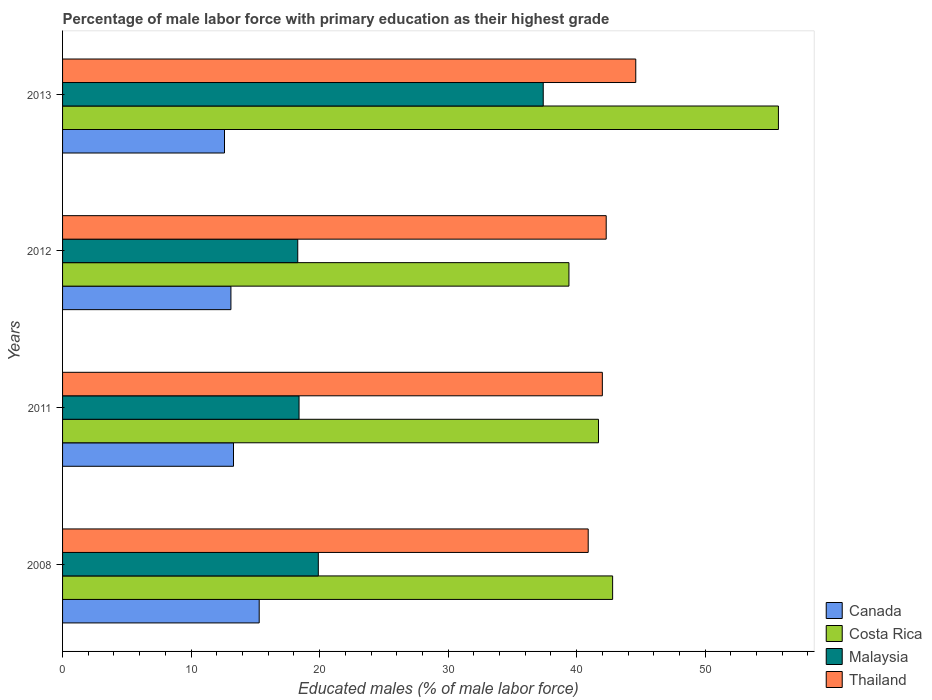How many bars are there on the 4th tick from the bottom?
Your response must be concise. 4. What is the label of the 3rd group of bars from the top?
Give a very brief answer. 2011. What is the percentage of male labor force with primary education in Malaysia in 2008?
Make the answer very short. 19.9. Across all years, what is the maximum percentage of male labor force with primary education in Malaysia?
Provide a succinct answer. 37.4. Across all years, what is the minimum percentage of male labor force with primary education in Thailand?
Offer a terse response. 40.9. In which year was the percentage of male labor force with primary education in Costa Rica maximum?
Provide a short and direct response. 2013. What is the total percentage of male labor force with primary education in Thailand in the graph?
Provide a succinct answer. 169.8. What is the difference between the percentage of male labor force with primary education in Malaysia in 2008 and that in 2012?
Your answer should be very brief. 1.6. What is the difference between the percentage of male labor force with primary education in Malaysia in 2011 and the percentage of male labor force with primary education in Thailand in 2008?
Keep it short and to the point. -22.5. What is the average percentage of male labor force with primary education in Canada per year?
Offer a very short reply. 13.58. In the year 2011, what is the difference between the percentage of male labor force with primary education in Costa Rica and percentage of male labor force with primary education in Malaysia?
Provide a succinct answer. 23.3. What is the ratio of the percentage of male labor force with primary education in Costa Rica in 2008 to that in 2013?
Ensure brevity in your answer.  0.77. What is the difference between the highest and the second highest percentage of male labor force with primary education in Malaysia?
Make the answer very short. 17.5. What is the difference between the highest and the lowest percentage of male labor force with primary education in Thailand?
Your answer should be compact. 3.7. In how many years, is the percentage of male labor force with primary education in Malaysia greater than the average percentage of male labor force with primary education in Malaysia taken over all years?
Offer a very short reply. 1. Is it the case that in every year, the sum of the percentage of male labor force with primary education in Canada and percentage of male labor force with primary education in Malaysia is greater than the sum of percentage of male labor force with primary education in Thailand and percentage of male labor force with primary education in Costa Rica?
Keep it short and to the point. No. What does the 4th bar from the top in 2012 represents?
Provide a succinct answer. Canada. What does the 3rd bar from the bottom in 2011 represents?
Make the answer very short. Malaysia. How many bars are there?
Offer a very short reply. 16. Are all the bars in the graph horizontal?
Provide a short and direct response. Yes. Where does the legend appear in the graph?
Offer a terse response. Bottom right. How many legend labels are there?
Your answer should be compact. 4. How are the legend labels stacked?
Give a very brief answer. Vertical. What is the title of the graph?
Offer a very short reply. Percentage of male labor force with primary education as their highest grade. What is the label or title of the X-axis?
Provide a short and direct response. Educated males (% of male labor force). What is the Educated males (% of male labor force) in Canada in 2008?
Offer a very short reply. 15.3. What is the Educated males (% of male labor force) of Costa Rica in 2008?
Offer a very short reply. 42.8. What is the Educated males (% of male labor force) in Malaysia in 2008?
Provide a short and direct response. 19.9. What is the Educated males (% of male labor force) of Thailand in 2008?
Keep it short and to the point. 40.9. What is the Educated males (% of male labor force) in Canada in 2011?
Offer a very short reply. 13.3. What is the Educated males (% of male labor force) of Costa Rica in 2011?
Offer a terse response. 41.7. What is the Educated males (% of male labor force) of Malaysia in 2011?
Your answer should be compact. 18.4. What is the Educated males (% of male labor force) in Thailand in 2011?
Give a very brief answer. 42. What is the Educated males (% of male labor force) in Canada in 2012?
Your answer should be compact. 13.1. What is the Educated males (% of male labor force) in Costa Rica in 2012?
Your answer should be very brief. 39.4. What is the Educated males (% of male labor force) in Malaysia in 2012?
Your answer should be compact. 18.3. What is the Educated males (% of male labor force) of Thailand in 2012?
Provide a short and direct response. 42.3. What is the Educated males (% of male labor force) of Canada in 2013?
Provide a succinct answer. 12.6. What is the Educated males (% of male labor force) in Costa Rica in 2013?
Offer a terse response. 55.7. What is the Educated males (% of male labor force) of Malaysia in 2013?
Your answer should be compact. 37.4. What is the Educated males (% of male labor force) in Thailand in 2013?
Offer a terse response. 44.6. Across all years, what is the maximum Educated males (% of male labor force) in Canada?
Offer a terse response. 15.3. Across all years, what is the maximum Educated males (% of male labor force) of Costa Rica?
Give a very brief answer. 55.7. Across all years, what is the maximum Educated males (% of male labor force) in Malaysia?
Your answer should be very brief. 37.4. Across all years, what is the maximum Educated males (% of male labor force) of Thailand?
Ensure brevity in your answer.  44.6. Across all years, what is the minimum Educated males (% of male labor force) of Canada?
Make the answer very short. 12.6. Across all years, what is the minimum Educated males (% of male labor force) in Costa Rica?
Your response must be concise. 39.4. Across all years, what is the minimum Educated males (% of male labor force) of Malaysia?
Your response must be concise. 18.3. Across all years, what is the minimum Educated males (% of male labor force) of Thailand?
Make the answer very short. 40.9. What is the total Educated males (% of male labor force) of Canada in the graph?
Offer a very short reply. 54.3. What is the total Educated males (% of male labor force) of Costa Rica in the graph?
Make the answer very short. 179.6. What is the total Educated males (% of male labor force) of Malaysia in the graph?
Offer a very short reply. 94. What is the total Educated males (% of male labor force) in Thailand in the graph?
Ensure brevity in your answer.  169.8. What is the difference between the Educated males (% of male labor force) of Costa Rica in 2008 and that in 2011?
Your answer should be very brief. 1.1. What is the difference between the Educated males (% of male labor force) in Malaysia in 2008 and that in 2011?
Offer a terse response. 1.5. What is the difference between the Educated males (% of male labor force) of Malaysia in 2008 and that in 2012?
Provide a short and direct response. 1.6. What is the difference between the Educated males (% of male labor force) in Canada in 2008 and that in 2013?
Your answer should be compact. 2.7. What is the difference between the Educated males (% of male labor force) of Malaysia in 2008 and that in 2013?
Offer a very short reply. -17.5. What is the difference between the Educated males (% of male labor force) of Thailand in 2008 and that in 2013?
Offer a terse response. -3.7. What is the difference between the Educated males (% of male labor force) in Canada in 2011 and that in 2012?
Keep it short and to the point. 0.2. What is the difference between the Educated males (% of male labor force) in Costa Rica in 2011 and that in 2012?
Ensure brevity in your answer.  2.3. What is the difference between the Educated males (% of male labor force) in Costa Rica in 2011 and that in 2013?
Keep it short and to the point. -14. What is the difference between the Educated males (% of male labor force) in Malaysia in 2011 and that in 2013?
Offer a very short reply. -19. What is the difference between the Educated males (% of male labor force) of Costa Rica in 2012 and that in 2013?
Ensure brevity in your answer.  -16.3. What is the difference between the Educated males (% of male labor force) of Malaysia in 2012 and that in 2013?
Provide a succinct answer. -19.1. What is the difference between the Educated males (% of male labor force) of Thailand in 2012 and that in 2013?
Provide a short and direct response. -2.3. What is the difference between the Educated males (% of male labor force) in Canada in 2008 and the Educated males (% of male labor force) in Costa Rica in 2011?
Keep it short and to the point. -26.4. What is the difference between the Educated males (% of male labor force) in Canada in 2008 and the Educated males (% of male labor force) in Thailand in 2011?
Your answer should be very brief. -26.7. What is the difference between the Educated males (% of male labor force) in Costa Rica in 2008 and the Educated males (% of male labor force) in Malaysia in 2011?
Offer a very short reply. 24.4. What is the difference between the Educated males (% of male labor force) of Malaysia in 2008 and the Educated males (% of male labor force) of Thailand in 2011?
Provide a succinct answer. -22.1. What is the difference between the Educated males (% of male labor force) in Canada in 2008 and the Educated males (% of male labor force) in Costa Rica in 2012?
Keep it short and to the point. -24.1. What is the difference between the Educated males (% of male labor force) of Canada in 2008 and the Educated males (% of male labor force) of Malaysia in 2012?
Your answer should be compact. -3. What is the difference between the Educated males (% of male labor force) of Canada in 2008 and the Educated males (% of male labor force) of Thailand in 2012?
Your answer should be compact. -27. What is the difference between the Educated males (% of male labor force) of Costa Rica in 2008 and the Educated males (% of male labor force) of Malaysia in 2012?
Offer a very short reply. 24.5. What is the difference between the Educated males (% of male labor force) in Malaysia in 2008 and the Educated males (% of male labor force) in Thailand in 2012?
Keep it short and to the point. -22.4. What is the difference between the Educated males (% of male labor force) of Canada in 2008 and the Educated males (% of male labor force) of Costa Rica in 2013?
Your answer should be compact. -40.4. What is the difference between the Educated males (% of male labor force) in Canada in 2008 and the Educated males (% of male labor force) in Malaysia in 2013?
Make the answer very short. -22.1. What is the difference between the Educated males (% of male labor force) of Canada in 2008 and the Educated males (% of male labor force) of Thailand in 2013?
Make the answer very short. -29.3. What is the difference between the Educated males (% of male labor force) of Costa Rica in 2008 and the Educated males (% of male labor force) of Malaysia in 2013?
Offer a very short reply. 5.4. What is the difference between the Educated males (% of male labor force) in Malaysia in 2008 and the Educated males (% of male labor force) in Thailand in 2013?
Provide a short and direct response. -24.7. What is the difference between the Educated males (% of male labor force) of Canada in 2011 and the Educated males (% of male labor force) of Costa Rica in 2012?
Offer a terse response. -26.1. What is the difference between the Educated males (% of male labor force) of Canada in 2011 and the Educated males (% of male labor force) of Malaysia in 2012?
Give a very brief answer. -5. What is the difference between the Educated males (% of male labor force) in Costa Rica in 2011 and the Educated males (% of male labor force) in Malaysia in 2012?
Keep it short and to the point. 23.4. What is the difference between the Educated males (% of male labor force) of Malaysia in 2011 and the Educated males (% of male labor force) of Thailand in 2012?
Offer a very short reply. -23.9. What is the difference between the Educated males (% of male labor force) in Canada in 2011 and the Educated males (% of male labor force) in Costa Rica in 2013?
Offer a terse response. -42.4. What is the difference between the Educated males (% of male labor force) of Canada in 2011 and the Educated males (% of male labor force) of Malaysia in 2013?
Provide a short and direct response. -24.1. What is the difference between the Educated males (% of male labor force) of Canada in 2011 and the Educated males (% of male labor force) of Thailand in 2013?
Make the answer very short. -31.3. What is the difference between the Educated males (% of male labor force) in Malaysia in 2011 and the Educated males (% of male labor force) in Thailand in 2013?
Offer a very short reply. -26.2. What is the difference between the Educated males (% of male labor force) of Canada in 2012 and the Educated males (% of male labor force) of Costa Rica in 2013?
Your answer should be compact. -42.6. What is the difference between the Educated males (% of male labor force) in Canada in 2012 and the Educated males (% of male labor force) in Malaysia in 2013?
Offer a very short reply. -24.3. What is the difference between the Educated males (% of male labor force) of Canada in 2012 and the Educated males (% of male labor force) of Thailand in 2013?
Your answer should be compact. -31.5. What is the difference between the Educated males (% of male labor force) in Costa Rica in 2012 and the Educated males (% of male labor force) in Malaysia in 2013?
Offer a very short reply. 2. What is the difference between the Educated males (% of male labor force) in Costa Rica in 2012 and the Educated males (% of male labor force) in Thailand in 2013?
Your response must be concise. -5.2. What is the difference between the Educated males (% of male labor force) of Malaysia in 2012 and the Educated males (% of male labor force) of Thailand in 2013?
Ensure brevity in your answer.  -26.3. What is the average Educated males (% of male labor force) of Canada per year?
Offer a very short reply. 13.57. What is the average Educated males (% of male labor force) of Costa Rica per year?
Ensure brevity in your answer.  44.9. What is the average Educated males (% of male labor force) in Thailand per year?
Your response must be concise. 42.45. In the year 2008, what is the difference between the Educated males (% of male labor force) of Canada and Educated males (% of male labor force) of Costa Rica?
Provide a short and direct response. -27.5. In the year 2008, what is the difference between the Educated males (% of male labor force) of Canada and Educated males (% of male labor force) of Malaysia?
Keep it short and to the point. -4.6. In the year 2008, what is the difference between the Educated males (% of male labor force) in Canada and Educated males (% of male labor force) in Thailand?
Offer a terse response. -25.6. In the year 2008, what is the difference between the Educated males (% of male labor force) in Costa Rica and Educated males (% of male labor force) in Malaysia?
Offer a terse response. 22.9. In the year 2011, what is the difference between the Educated males (% of male labor force) in Canada and Educated males (% of male labor force) in Costa Rica?
Offer a terse response. -28.4. In the year 2011, what is the difference between the Educated males (% of male labor force) of Canada and Educated males (% of male labor force) of Malaysia?
Offer a very short reply. -5.1. In the year 2011, what is the difference between the Educated males (% of male labor force) in Canada and Educated males (% of male labor force) in Thailand?
Provide a succinct answer. -28.7. In the year 2011, what is the difference between the Educated males (% of male labor force) of Costa Rica and Educated males (% of male labor force) of Malaysia?
Give a very brief answer. 23.3. In the year 2011, what is the difference between the Educated males (% of male labor force) of Malaysia and Educated males (% of male labor force) of Thailand?
Offer a very short reply. -23.6. In the year 2012, what is the difference between the Educated males (% of male labor force) of Canada and Educated males (% of male labor force) of Costa Rica?
Offer a terse response. -26.3. In the year 2012, what is the difference between the Educated males (% of male labor force) of Canada and Educated males (% of male labor force) of Malaysia?
Your response must be concise. -5.2. In the year 2012, what is the difference between the Educated males (% of male labor force) in Canada and Educated males (% of male labor force) in Thailand?
Give a very brief answer. -29.2. In the year 2012, what is the difference between the Educated males (% of male labor force) of Costa Rica and Educated males (% of male labor force) of Malaysia?
Ensure brevity in your answer.  21.1. In the year 2012, what is the difference between the Educated males (% of male labor force) in Malaysia and Educated males (% of male labor force) in Thailand?
Provide a short and direct response. -24. In the year 2013, what is the difference between the Educated males (% of male labor force) in Canada and Educated males (% of male labor force) in Costa Rica?
Make the answer very short. -43.1. In the year 2013, what is the difference between the Educated males (% of male labor force) in Canada and Educated males (% of male labor force) in Malaysia?
Your response must be concise. -24.8. In the year 2013, what is the difference between the Educated males (% of male labor force) of Canada and Educated males (% of male labor force) of Thailand?
Keep it short and to the point. -32. In the year 2013, what is the difference between the Educated males (% of male labor force) in Malaysia and Educated males (% of male labor force) in Thailand?
Give a very brief answer. -7.2. What is the ratio of the Educated males (% of male labor force) of Canada in 2008 to that in 2011?
Make the answer very short. 1.15. What is the ratio of the Educated males (% of male labor force) in Costa Rica in 2008 to that in 2011?
Provide a short and direct response. 1.03. What is the ratio of the Educated males (% of male labor force) of Malaysia in 2008 to that in 2011?
Provide a succinct answer. 1.08. What is the ratio of the Educated males (% of male labor force) in Thailand in 2008 to that in 2011?
Make the answer very short. 0.97. What is the ratio of the Educated males (% of male labor force) of Canada in 2008 to that in 2012?
Your answer should be very brief. 1.17. What is the ratio of the Educated males (% of male labor force) in Costa Rica in 2008 to that in 2012?
Offer a terse response. 1.09. What is the ratio of the Educated males (% of male labor force) of Malaysia in 2008 to that in 2012?
Offer a very short reply. 1.09. What is the ratio of the Educated males (% of male labor force) of Thailand in 2008 to that in 2012?
Make the answer very short. 0.97. What is the ratio of the Educated males (% of male labor force) of Canada in 2008 to that in 2013?
Make the answer very short. 1.21. What is the ratio of the Educated males (% of male labor force) in Costa Rica in 2008 to that in 2013?
Give a very brief answer. 0.77. What is the ratio of the Educated males (% of male labor force) of Malaysia in 2008 to that in 2013?
Your answer should be compact. 0.53. What is the ratio of the Educated males (% of male labor force) in Thailand in 2008 to that in 2013?
Your response must be concise. 0.92. What is the ratio of the Educated males (% of male labor force) of Canada in 2011 to that in 2012?
Ensure brevity in your answer.  1.02. What is the ratio of the Educated males (% of male labor force) of Costa Rica in 2011 to that in 2012?
Your answer should be compact. 1.06. What is the ratio of the Educated males (% of male labor force) of Malaysia in 2011 to that in 2012?
Your answer should be compact. 1.01. What is the ratio of the Educated males (% of male labor force) of Thailand in 2011 to that in 2012?
Your response must be concise. 0.99. What is the ratio of the Educated males (% of male labor force) of Canada in 2011 to that in 2013?
Provide a short and direct response. 1.06. What is the ratio of the Educated males (% of male labor force) of Costa Rica in 2011 to that in 2013?
Keep it short and to the point. 0.75. What is the ratio of the Educated males (% of male labor force) in Malaysia in 2011 to that in 2013?
Keep it short and to the point. 0.49. What is the ratio of the Educated males (% of male labor force) of Thailand in 2011 to that in 2013?
Your response must be concise. 0.94. What is the ratio of the Educated males (% of male labor force) of Canada in 2012 to that in 2013?
Give a very brief answer. 1.04. What is the ratio of the Educated males (% of male labor force) of Costa Rica in 2012 to that in 2013?
Give a very brief answer. 0.71. What is the ratio of the Educated males (% of male labor force) in Malaysia in 2012 to that in 2013?
Ensure brevity in your answer.  0.49. What is the ratio of the Educated males (% of male labor force) in Thailand in 2012 to that in 2013?
Ensure brevity in your answer.  0.95. What is the difference between the highest and the second highest Educated males (% of male labor force) in Thailand?
Keep it short and to the point. 2.3. What is the difference between the highest and the lowest Educated males (% of male labor force) in Canada?
Offer a terse response. 2.7. 